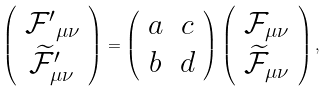Convert formula to latex. <formula><loc_0><loc_0><loc_500><loc_500>\left ( \begin{array} { c } { \mathcal { F } ^ { \prime } } _ { \mu \nu } \\ \widetilde { \mathcal { F } } _ { \mu \nu } ^ { \prime } \end{array} \right ) = \left ( \begin{array} { c c } a & c \\ b & d \end{array} \right ) \left ( \begin{array} { c } \mathcal { F } _ { \mu \nu } \\ \widetilde { \mathcal { F } } _ { \mu \nu } \end{array} \right ) ,</formula> 